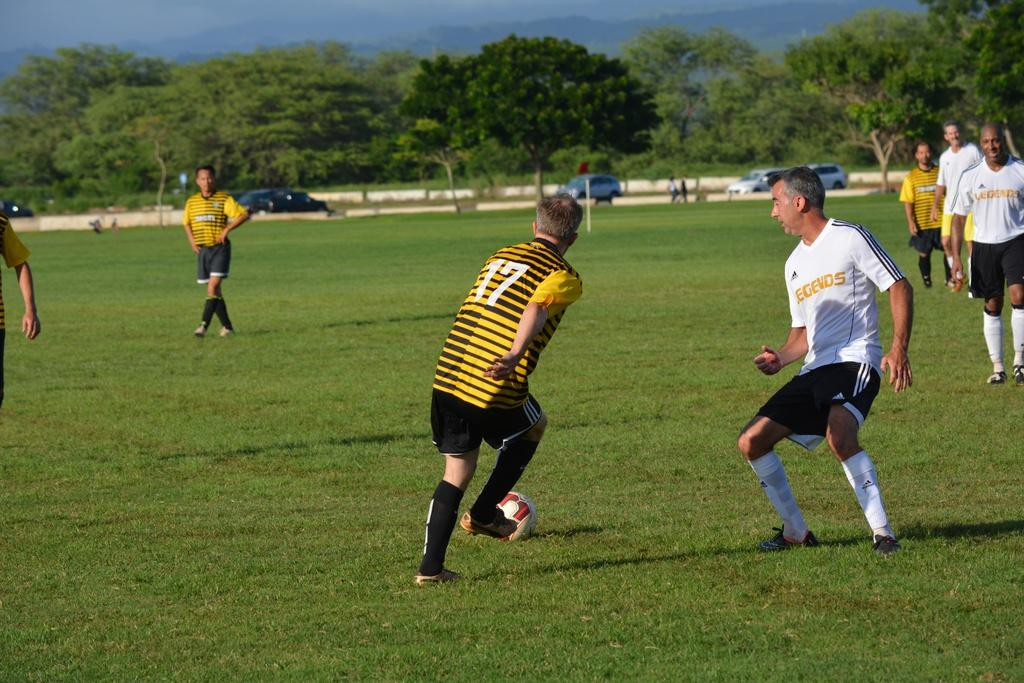What activity are the people in the image engaged in? The people in the image are playing football. What is the surface of the football field made of? The football field is grassy. What action is the man in the image attempting to perform? The man is trying to kick the ball. What can be seen in the background of the image? There are trees and cars in the background of the image. What type of basin is being used to catch the football in the image? There is no basin present in the image; the football is being played on a grassy field. What color is the copper used to make the football in the image? The football is not made of copper; it is a standard football made of leather or synthetic materials. 